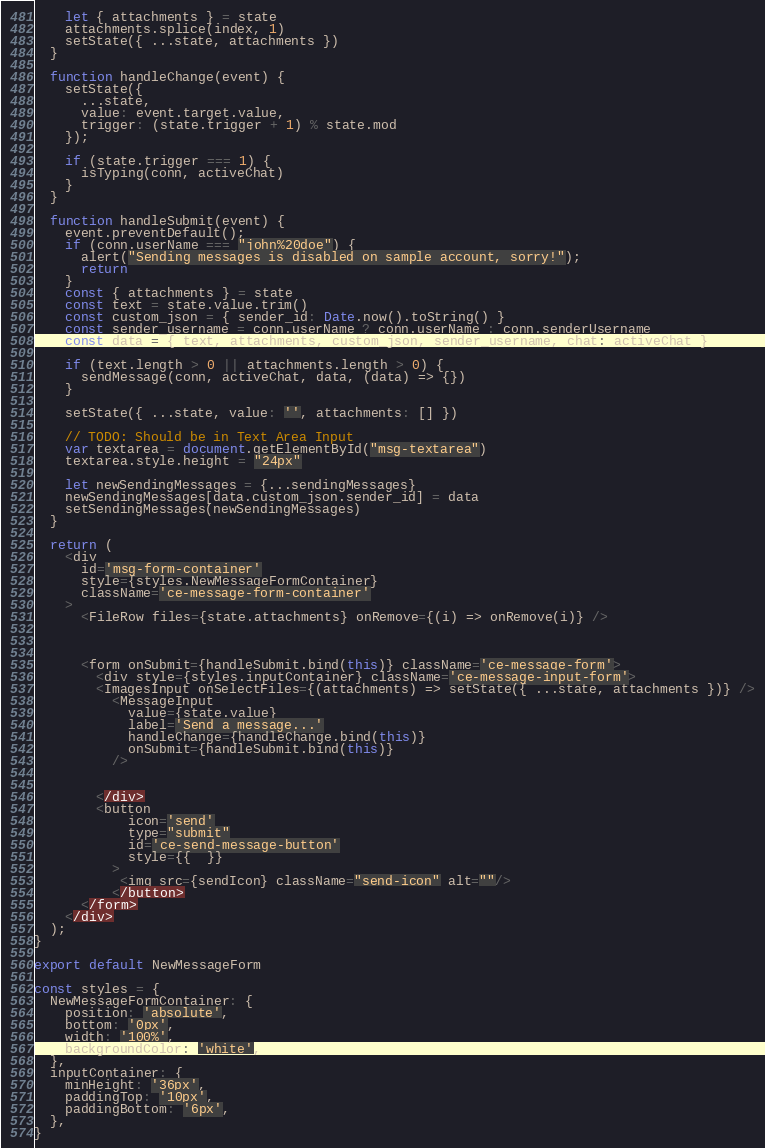<code> <loc_0><loc_0><loc_500><loc_500><_JavaScript_>    let { attachments } = state 
    attachments.splice(index, 1)
    setState({ ...state, attachments })
  }
  
  function handleChange(event) {
    setState({
      ...state,
      value: event.target.value,
      trigger: (state.trigger + 1) % state.mod
    });
    
    if (state.trigger === 1) {
      isTyping(conn, activeChat)
    }
  }

  function handleSubmit(event) {
    event.preventDefault();
    if (conn.userName === "john%20doe") {
      alert("Sending messages is disabled on sample account, sorry!");
      return
    }
    const { attachments } = state
    const text = state.value.trim()
    const custom_json = { sender_id: Date.now().toString() }
    const sender_username = conn.userName ? conn.userName : conn.senderUsername
    const data = { text, attachments, custom_json, sender_username, chat: activeChat }

    if (text.length > 0 || attachments.length > 0) {
      sendMessage(conn, activeChat, data, (data) => {})
    }

    setState({ ...state, value: '', attachments: [] })
    
    // TODO: Should be in Text Area Input
    var textarea = document.getElementById("msg-textarea")
    textarea.style.height = "24px"

    let newSendingMessages = {...sendingMessages}
    newSendingMessages[data.custom_json.sender_id] = data
    setSendingMessages(newSendingMessages)
  }

  return (
    <div 
      id='msg-form-container'
      style={styles.NewMessageFormContainer}
      className='ce-message-form-container'
    >
      <FileRow files={state.attachments} onRemove={(i) => onRemove(i)} />

      

      <form onSubmit={handleSubmit.bind(this)} className='ce-message-form'>
        <div style={styles.inputContainer} className='ce-message-input-form'>
        <ImagesInput onSelectFiles={(attachments) => setState({ ...state, attachments })} />
          <MessageInput
            value={state.value}
            label='Send a message...'
            handleChange={handleChange.bind(this)}
            onSubmit={handleSubmit.bind(this)}
          />

         
        </div>
        <button 
            icon='send'
            type="submit"
            id='ce-send-message-button'
            style={{  }}
          >
           <img src={sendIcon} className="send-icon" alt=""/>
          </button>
      </form>
    </div>
  );
}

export default NewMessageForm

const styles = {
  NewMessageFormContainer: { 
    position: 'absolute', 
    bottom: '0px', 
    width: '100%', 
    backgroundColor: 'white',
  },
  inputContainer: { 
    minHeight: '36px',
    paddingTop: '10px',
    paddingBottom: '6px',
  },
}</code> 